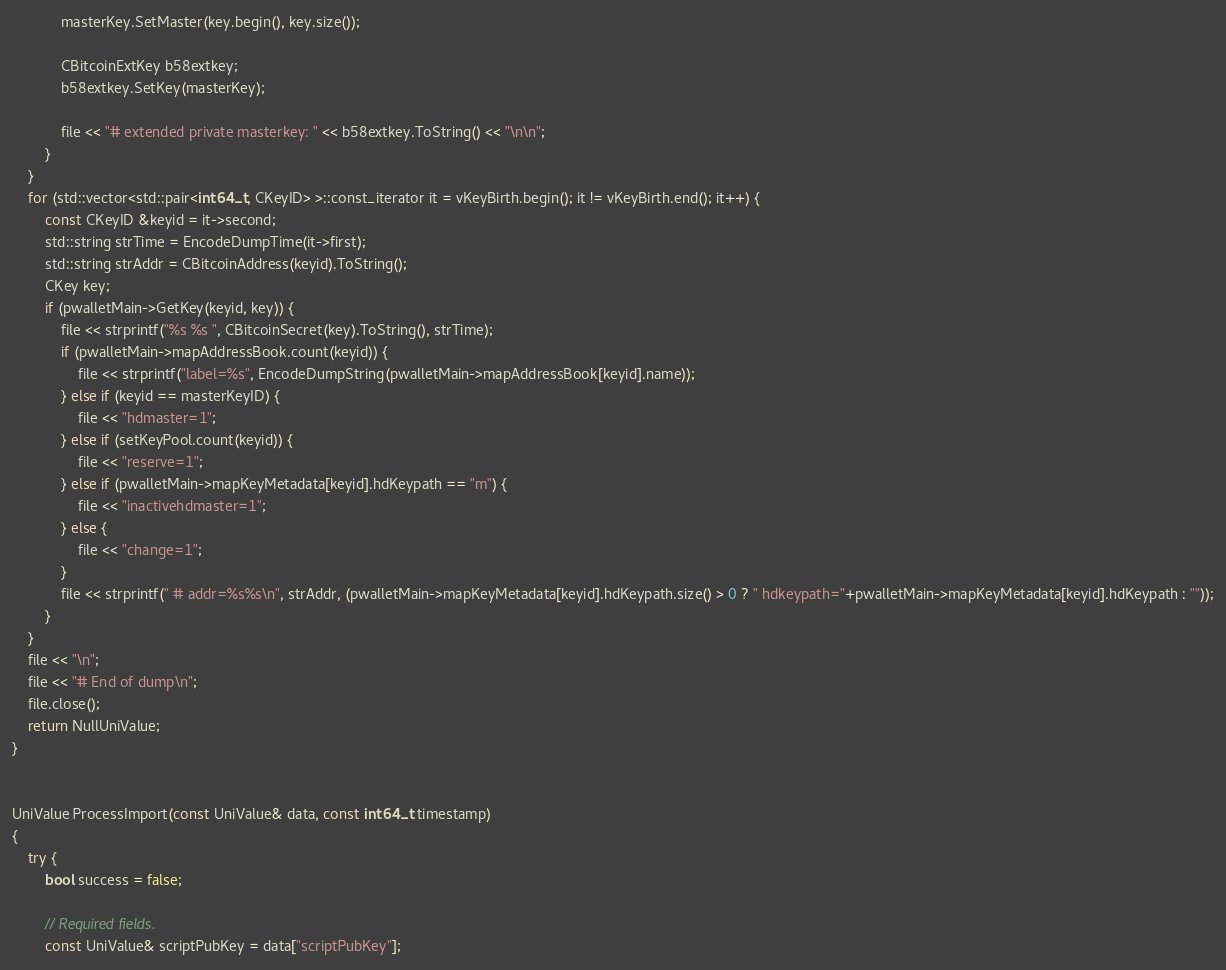Convert code to text. <code><loc_0><loc_0><loc_500><loc_500><_C++_>            masterKey.SetMaster(key.begin(), key.size());

            CBitcoinExtKey b58extkey;
            b58extkey.SetKey(masterKey);

            file << "# extended private masterkey: " << b58extkey.ToString() << "\n\n";
        }
    }
    for (std::vector<std::pair<int64_t, CKeyID> >::const_iterator it = vKeyBirth.begin(); it != vKeyBirth.end(); it++) {
        const CKeyID &keyid = it->second;
        std::string strTime = EncodeDumpTime(it->first);
        std::string strAddr = CBitcoinAddress(keyid).ToString();
        CKey key;
        if (pwalletMain->GetKey(keyid, key)) {
            file << strprintf("%s %s ", CBitcoinSecret(key).ToString(), strTime);
            if (pwalletMain->mapAddressBook.count(keyid)) {
                file << strprintf("label=%s", EncodeDumpString(pwalletMain->mapAddressBook[keyid].name));
            } else if (keyid == masterKeyID) {
                file << "hdmaster=1";
            } else if (setKeyPool.count(keyid)) {
                file << "reserve=1";
            } else if (pwalletMain->mapKeyMetadata[keyid].hdKeypath == "m") {
                file << "inactivehdmaster=1";
            } else {
                file << "change=1";
            }
            file << strprintf(" # addr=%s%s\n", strAddr, (pwalletMain->mapKeyMetadata[keyid].hdKeypath.size() > 0 ? " hdkeypath="+pwalletMain->mapKeyMetadata[keyid].hdKeypath : ""));
        }
    }
    file << "\n";
    file << "# End of dump\n";
    file.close();
    return NullUniValue;
}


UniValue ProcessImport(const UniValue& data, const int64_t timestamp)
{
    try {
        bool success = false;

        // Required fields.
        const UniValue& scriptPubKey = data["scriptPubKey"];
</code> 